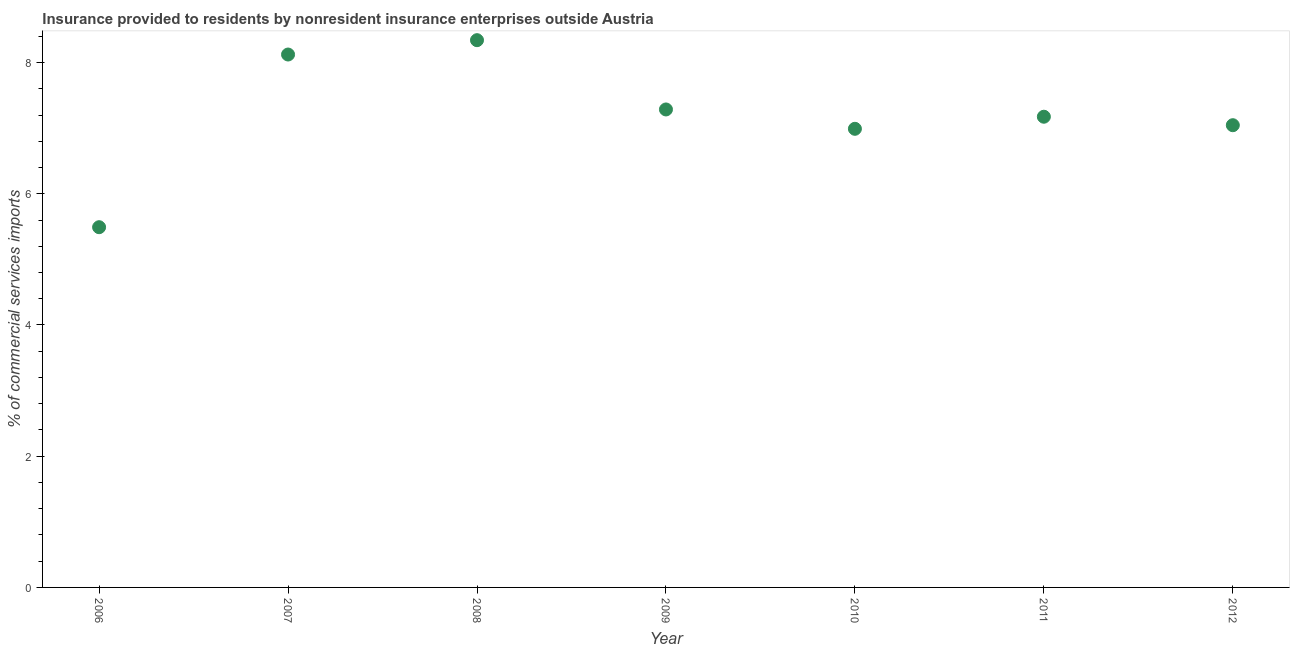What is the insurance provided by non-residents in 2012?
Keep it short and to the point. 7.05. Across all years, what is the maximum insurance provided by non-residents?
Ensure brevity in your answer.  8.34. Across all years, what is the minimum insurance provided by non-residents?
Offer a very short reply. 5.49. What is the sum of the insurance provided by non-residents?
Your response must be concise. 50.45. What is the difference between the insurance provided by non-residents in 2006 and 2010?
Make the answer very short. -1.5. What is the average insurance provided by non-residents per year?
Provide a succinct answer. 7.21. What is the median insurance provided by non-residents?
Offer a very short reply. 7.17. In how many years, is the insurance provided by non-residents greater than 3.6 %?
Your response must be concise. 7. Do a majority of the years between 2010 and 2008 (inclusive) have insurance provided by non-residents greater than 3.6 %?
Your answer should be very brief. No. What is the ratio of the insurance provided by non-residents in 2006 to that in 2008?
Ensure brevity in your answer.  0.66. Is the insurance provided by non-residents in 2007 less than that in 2010?
Provide a succinct answer. No. Is the difference between the insurance provided by non-residents in 2008 and 2011 greater than the difference between any two years?
Provide a succinct answer. No. What is the difference between the highest and the second highest insurance provided by non-residents?
Offer a very short reply. 0.22. What is the difference between the highest and the lowest insurance provided by non-residents?
Make the answer very short. 2.85. In how many years, is the insurance provided by non-residents greater than the average insurance provided by non-residents taken over all years?
Offer a terse response. 3. How many years are there in the graph?
Make the answer very short. 7. What is the difference between two consecutive major ticks on the Y-axis?
Your answer should be compact. 2. Are the values on the major ticks of Y-axis written in scientific E-notation?
Keep it short and to the point. No. What is the title of the graph?
Make the answer very short. Insurance provided to residents by nonresident insurance enterprises outside Austria. What is the label or title of the X-axis?
Give a very brief answer. Year. What is the label or title of the Y-axis?
Make the answer very short. % of commercial services imports. What is the % of commercial services imports in 2006?
Give a very brief answer. 5.49. What is the % of commercial services imports in 2007?
Keep it short and to the point. 8.12. What is the % of commercial services imports in 2008?
Provide a short and direct response. 8.34. What is the % of commercial services imports in 2009?
Provide a short and direct response. 7.29. What is the % of commercial services imports in 2010?
Ensure brevity in your answer.  6.99. What is the % of commercial services imports in 2011?
Give a very brief answer. 7.17. What is the % of commercial services imports in 2012?
Your answer should be compact. 7.05. What is the difference between the % of commercial services imports in 2006 and 2007?
Keep it short and to the point. -2.63. What is the difference between the % of commercial services imports in 2006 and 2008?
Offer a very short reply. -2.85. What is the difference between the % of commercial services imports in 2006 and 2009?
Provide a succinct answer. -1.79. What is the difference between the % of commercial services imports in 2006 and 2010?
Your answer should be very brief. -1.5. What is the difference between the % of commercial services imports in 2006 and 2011?
Your answer should be compact. -1.68. What is the difference between the % of commercial services imports in 2006 and 2012?
Give a very brief answer. -1.55. What is the difference between the % of commercial services imports in 2007 and 2008?
Ensure brevity in your answer.  -0.22. What is the difference between the % of commercial services imports in 2007 and 2009?
Your answer should be very brief. 0.84. What is the difference between the % of commercial services imports in 2007 and 2010?
Your answer should be very brief. 1.13. What is the difference between the % of commercial services imports in 2007 and 2011?
Offer a very short reply. 0.95. What is the difference between the % of commercial services imports in 2007 and 2012?
Offer a very short reply. 1.08. What is the difference between the % of commercial services imports in 2008 and 2009?
Your answer should be very brief. 1.06. What is the difference between the % of commercial services imports in 2008 and 2010?
Offer a very short reply. 1.35. What is the difference between the % of commercial services imports in 2008 and 2011?
Keep it short and to the point. 1.17. What is the difference between the % of commercial services imports in 2008 and 2012?
Your answer should be very brief. 1.3. What is the difference between the % of commercial services imports in 2009 and 2010?
Give a very brief answer. 0.29. What is the difference between the % of commercial services imports in 2009 and 2011?
Offer a very short reply. 0.11. What is the difference between the % of commercial services imports in 2009 and 2012?
Keep it short and to the point. 0.24. What is the difference between the % of commercial services imports in 2010 and 2011?
Make the answer very short. -0.18. What is the difference between the % of commercial services imports in 2010 and 2012?
Ensure brevity in your answer.  -0.05. What is the difference between the % of commercial services imports in 2011 and 2012?
Ensure brevity in your answer.  0.13. What is the ratio of the % of commercial services imports in 2006 to that in 2007?
Provide a short and direct response. 0.68. What is the ratio of the % of commercial services imports in 2006 to that in 2008?
Keep it short and to the point. 0.66. What is the ratio of the % of commercial services imports in 2006 to that in 2009?
Offer a terse response. 0.75. What is the ratio of the % of commercial services imports in 2006 to that in 2010?
Provide a succinct answer. 0.79. What is the ratio of the % of commercial services imports in 2006 to that in 2011?
Give a very brief answer. 0.77. What is the ratio of the % of commercial services imports in 2006 to that in 2012?
Give a very brief answer. 0.78. What is the ratio of the % of commercial services imports in 2007 to that in 2009?
Offer a very short reply. 1.11. What is the ratio of the % of commercial services imports in 2007 to that in 2010?
Provide a succinct answer. 1.16. What is the ratio of the % of commercial services imports in 2007 to that in 2011?
Keep it short and to the point. 1.13. What is the ratio of the % of commercial services imports in 2007 to that in 2012?
Make the answer very short. 1.15. What is the ratio of the % of commercial services imports in 2008 to that in 2009?
Ensure brevity in your answer.  1.15. What is the ratio of the % of commercial services imports in 2008 to that in 2010?
Your response must be concise. 1.19. What is the ratio of the % of commercial services imports in 2008 to that in 2011?
Provide a succinct answer. 1.16. What is the ratio of the % of commercial services imports in 2008 to that in 2012?
Ensure brevity in your answer.  1.18. What is the ratio of the % of commercial services imports in 2009 to that in 2010?
Provide a short and direct response. 1.04. What is the ratio of the % of commercial services imports in 2009 to that in 2012?
Give a very brief answer. 1.03. What is the ratio of the % of commercial services imports in 2010 to that in 2011?
Give a very brief answer. 0.97. 